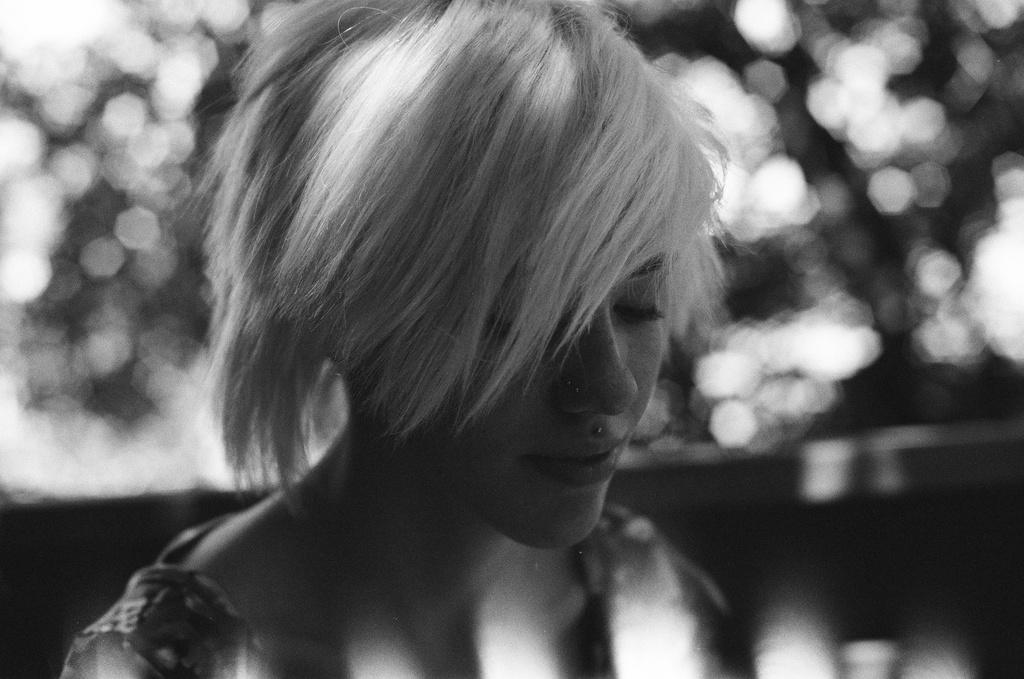Who is present in the image? There is a woman in the image. What is the woman's facial expression? The woman is smiling. Can you describe the background of the image? The background of the image is blurry. What type of card is the woman holding in the image? There is no card present in the image. How does the woman's behavior change throughout the image? The image only shows a single moment, so it is impossible to determine any changes in the woman's behavior. 